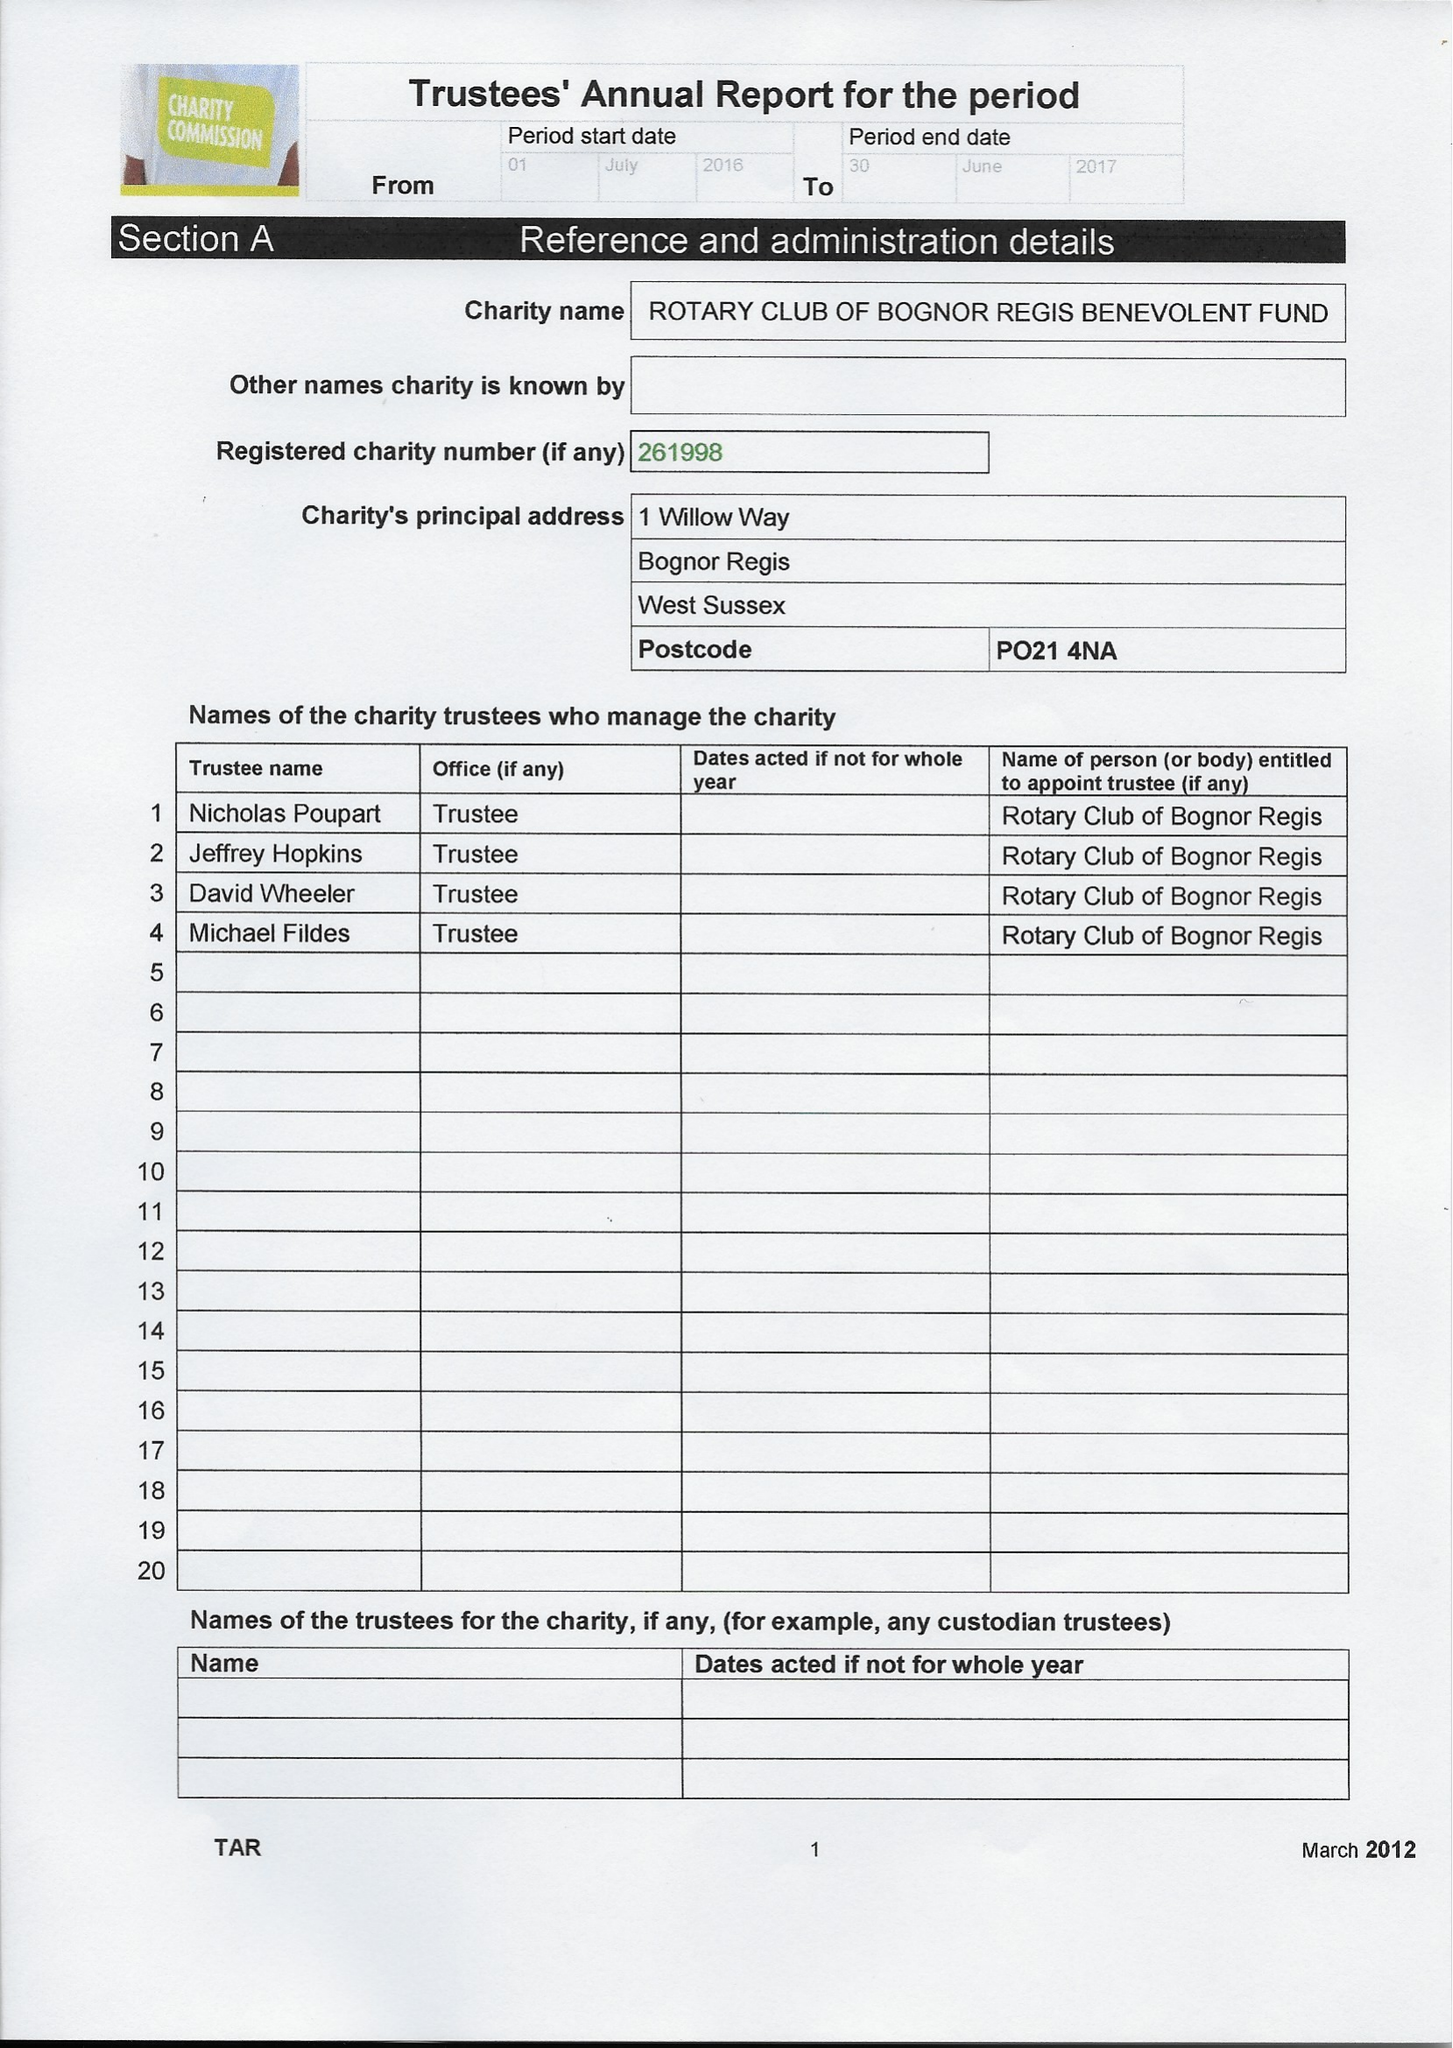What is the value for the address__postcode?
Answer the question using a single word or phrase. PO21 4NA 